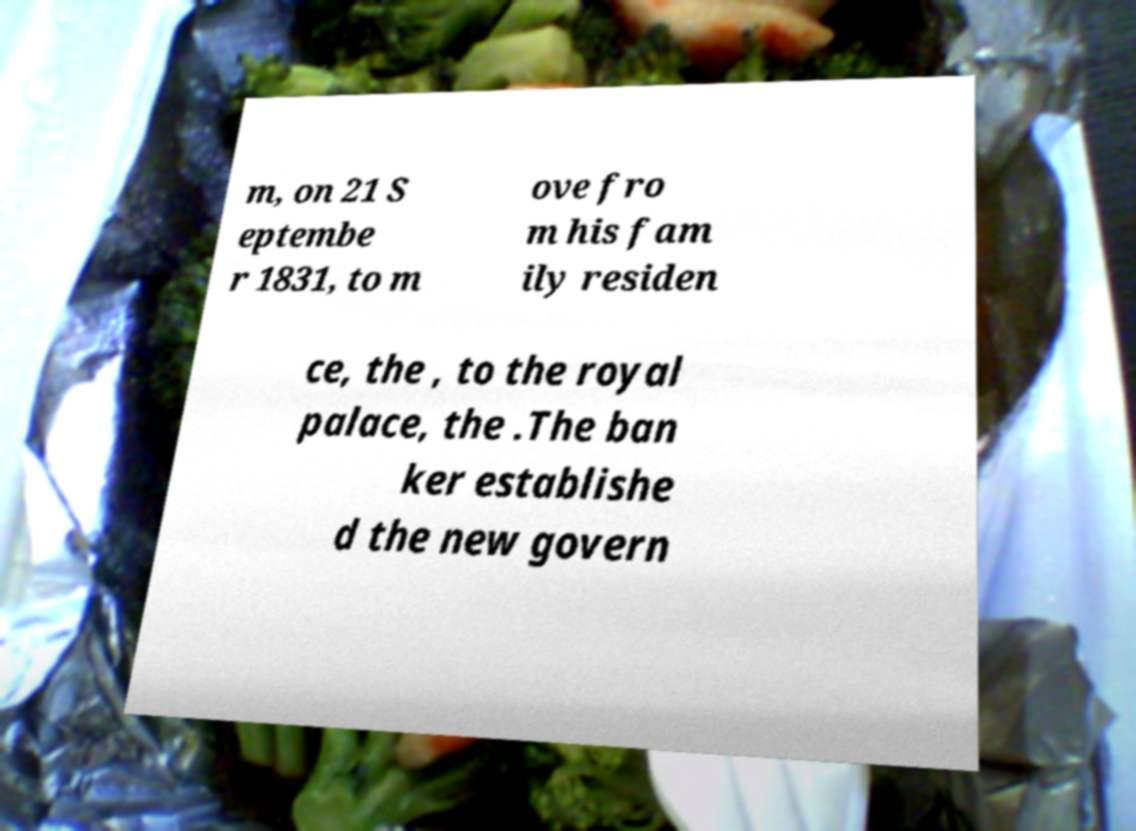Could you assist in decoding the text presented in this image and type it out clearly? m, on 21 S eptembe r 1831, to m ove fro m his fam ily residen ce, the , to the royal palace, the .The ban ker establishe d the new govern 